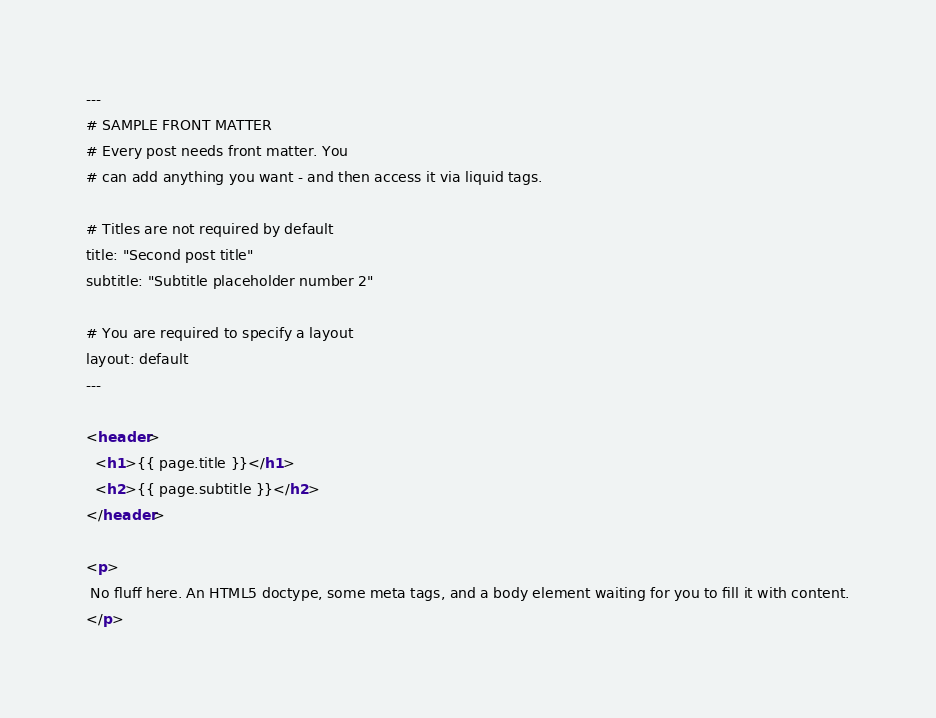Convert code to text. <code><loc_0><loc_0><loc_500><loc_500><_HTML_>---
# SAMPLE FRONT MATTER
# Every post needs front matter. You
# can add anything you want - and then access it via liquid tags.

# Titles are not required by default
title: "Second post title"
subtitle: "Subtitle placeholder number 2"

# You are required to specify a layout
layout: default
---

<header>
  <h1>{{ page.title }}</h1>
  <h2>{{ page.subtitle }}</h2>
</header>

<p>
 No fluff here. An HTML5 doctype, some meta tags, and a body element waiting for you to fill it with content.
</p>

</code> 